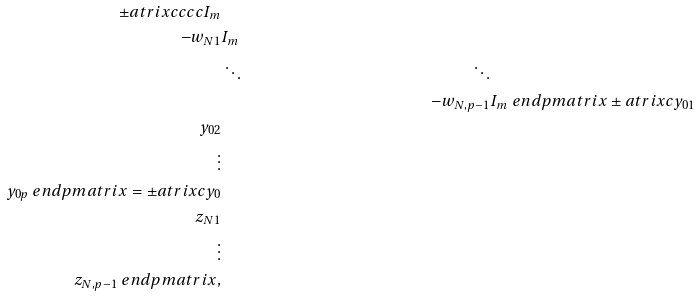Convert formula to latex. <formula><loc_0><loc_0><loc_500><loc_500>\pm a t r i x { c c c c } I _ { m } \\ - w _ { N 1 } & I _ { m } \\ & \ddots & \ddots \\ & & - w _ { N , p - 1 } & I _ { m } \ e n d p m a t r i x \pm a t r i x { c } y _ { 0 1 } \\ y _ { 0 2 } \\ \vdots \\ y _ { 0 p } \ e n d p m a t r i x = \pm a t r i x { c } y _ { 0 } \\ z _ { N 1 } \\ \vdots \\ z _ { N , p - 1 } \ e n d p m a t r i x ,</formula> 